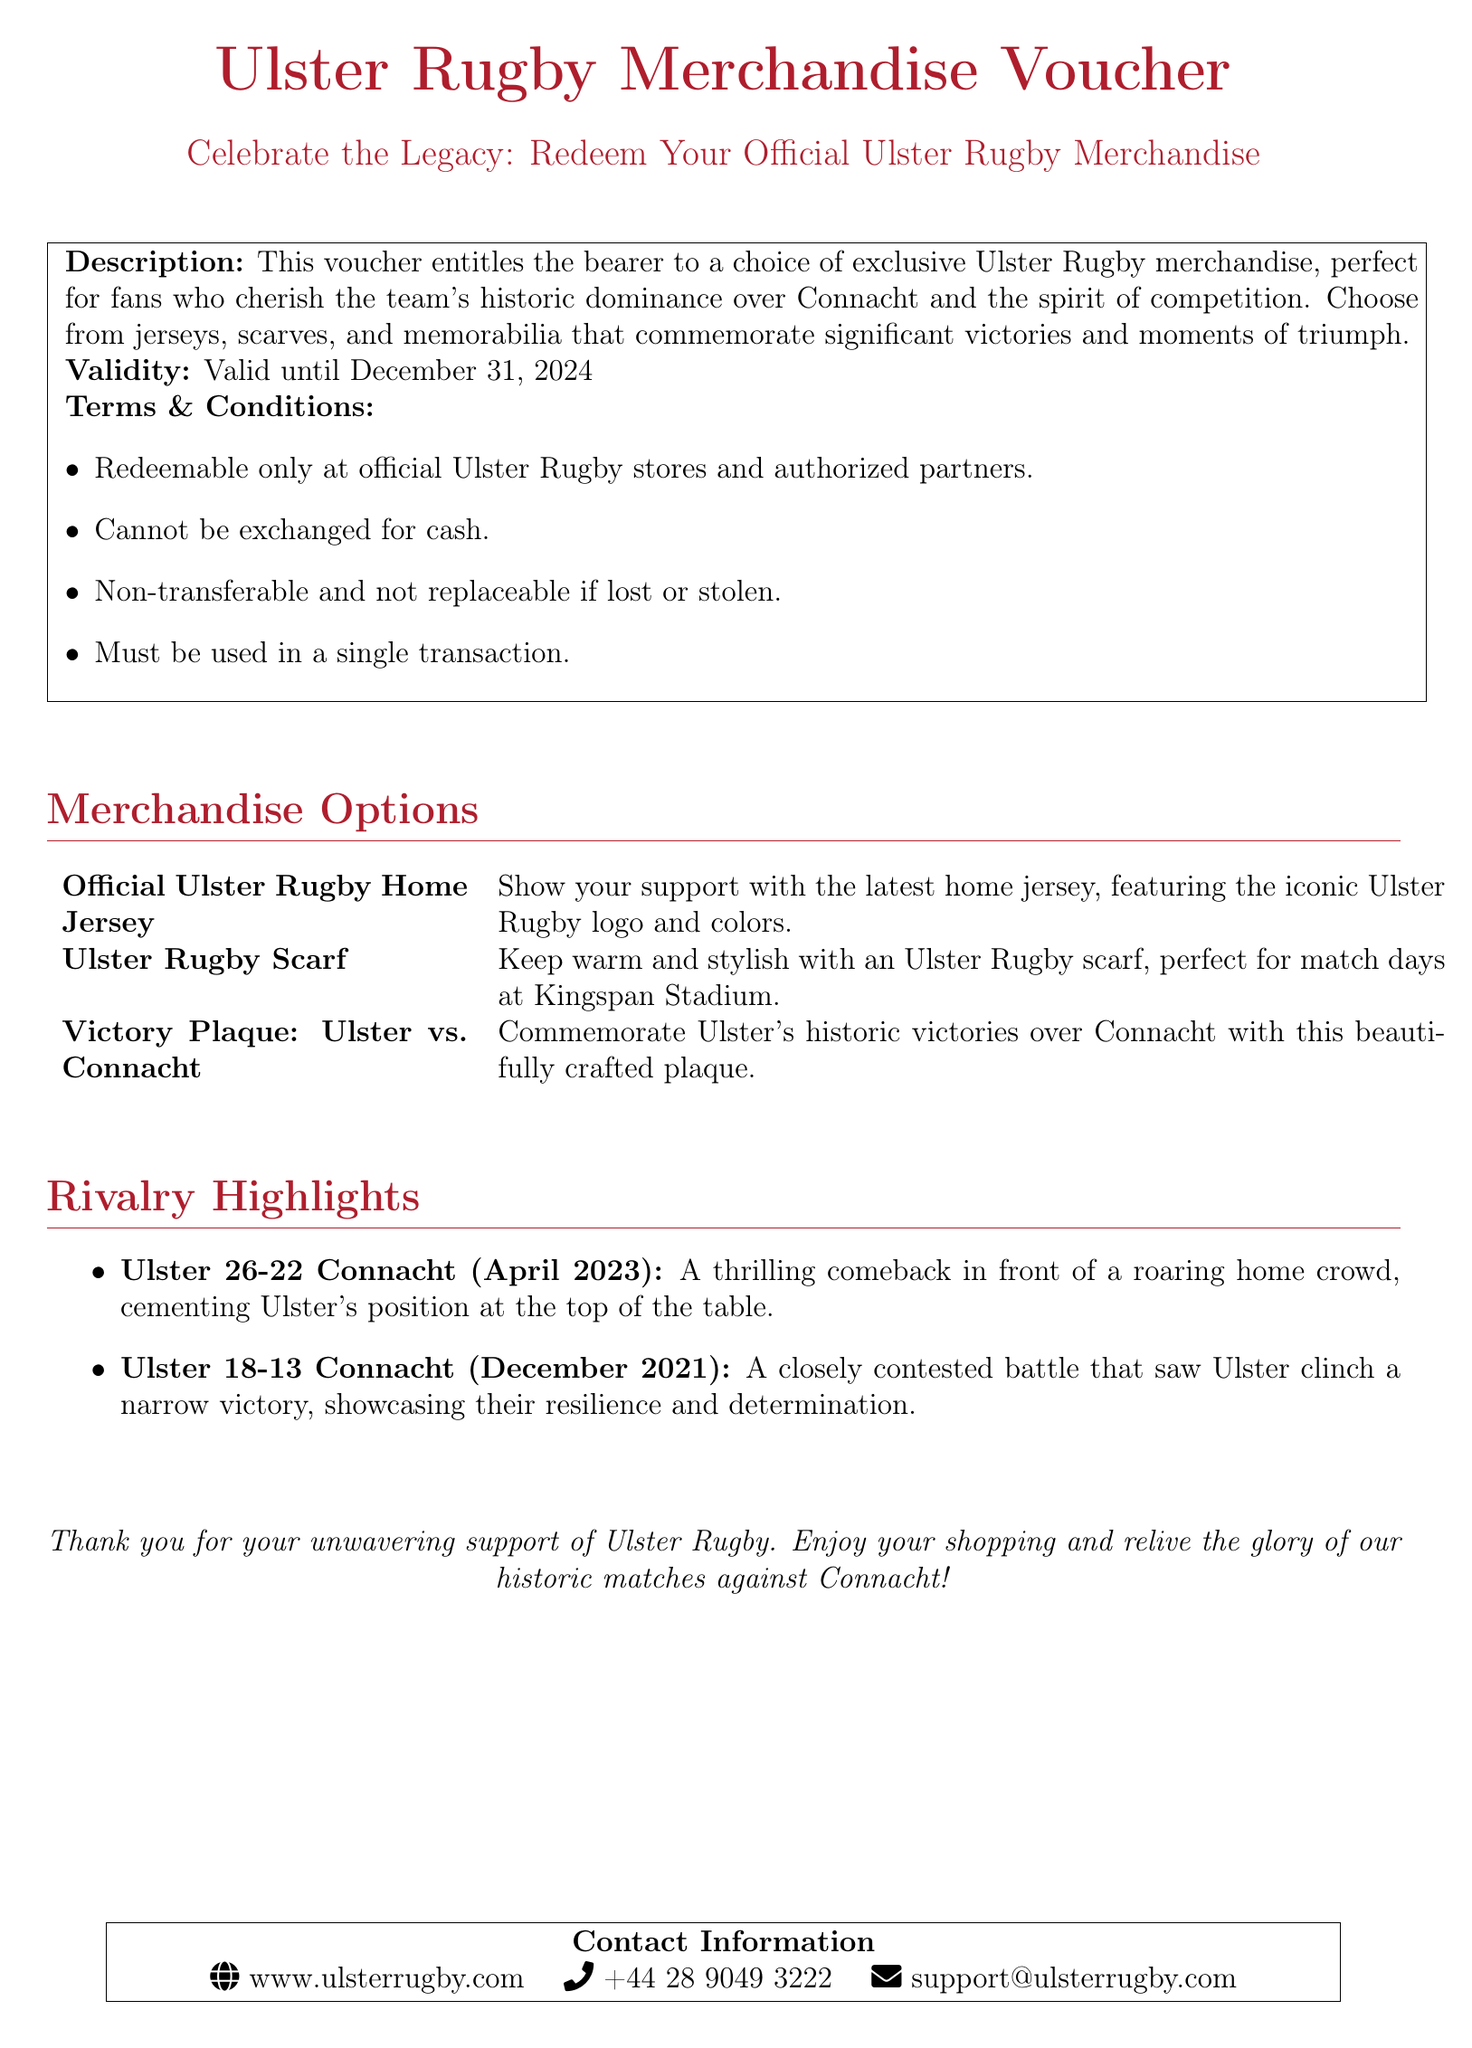What is the validity period of the voucher? The validity period is specified in the document as valid until December 31, 2024.
Answer: December 31, 2024 What merchandise can be redeemed with this voucher? The document lists exclusive Ulster Rugby merchandise such as jerseys, scarves, and memorabilia.
Answer: Jerseys, scarves, memorabilia What is one of the rivalry highlights mentioned? The document provides examples of thrilling matches between Ulster and Connacht as highlights, such as the match from April 2023.
Answer: Ulster 26-22 Connacht (April 2023) Is the voucher transferable? The terms and conditions state that the voucher is non-transferable.
Answer: Non-transferable Where can the voucher be redeemed? According to the terms and conditions, it can be redeemed only at official Ulster Rugby stores and authorized partners.
Answer: Official Ulster Rugby stores What color is associated with Ulster Rugby in the document? The document uses the color code RGB for Ulster red throughout, which signifies Ulster Rugby.
Answer: Ulster red 